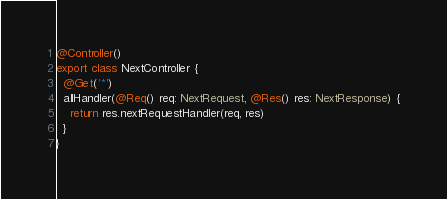Convert code to text. <code><loc_0><loc_0><loc_500><loc_500><_TypeScript_>
@Controller()
export class NextController {
  @Get('*')
  allHandler(@Req() req: NextRequest, @Res() res: NextResponse) {
    return res.nextRequestHandler(req, res)
  }
}
</code> 